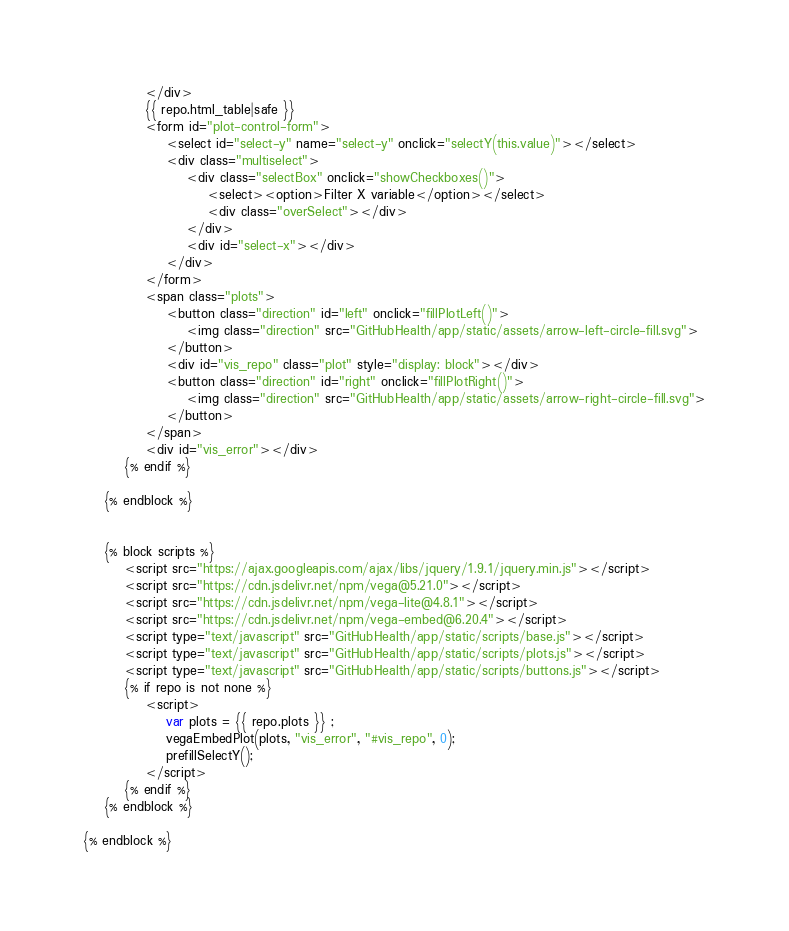Convert code to text. <code><loc_0><loc_0><loc_500><loc_500><_HTML_>            </div>
            {{ repo.html_table|safe }}
            <form id="plot-control-form">
                <select id="select-y" name="select-y" onclick="selectY(this.value)"></select>
                <div class="multiselect">
                    <div class="selectBox" onclick="showCheckboxes()">
                        <select><option>Filter X variable</option></select>
                        <div class="overSelect"></div>
                    </div>
                    <div id="select-x"></div>
                </div>
            </form>
            <span class="plots">
                <button class="direction" id="left" onclick="fillPlotLeft()">
                    <img class="direction" src="GitHubHealth/app/static/assets/arrow-left-circle-fill.svg">
                </button>
                <div id="vis_repo" class="plot" style="display: block"></div>
                <button class="direction" id="right" onclick="fillPlotRight()">
                    <img class="direction" src="GitHubHealth/app/static/assets/arrow-right-circle-fill.svg">
                </button>
            </span>
            <div id="vis_error"></div>
        {% endif %}

    {% endblock %}


    {% block scripts %}
        <script src="https://ajax.googleapis.com/ajax/libs/jquery/1.9.1/jquery.min.js"></script>
        <script src="https://cdn.jsdelivr.net/npm/vega@5.21.0"></script>
        <script src="https://cdn.jsdelivr.net/npm/vega-lite@4.8.1"></script>
        <script src="https://cdn.jsdelivr.net/npm/vega-embed@6.20.4"></script>
        <script type="text/javascript" src="GitHubHealth/app/static/scripts/base.js"></script>
        <script type="text/javascript" src="GitHubHealth/app/static/scripts/plots.js"></script>
        <script type="text/javascript" src="GitHubHealth/app/static/scripts/buttons.js"></script>
        {% if repo is not none %}
            <script>
                var plots = {{ repo.plots }} ;
                vegaEmbedPlot(plots, "vis_error", "#vis_repo", 0);
                prefillSelectY();
            </script>
        {% endif %}
    {% endblock %}

{% endblock %}
</code> 